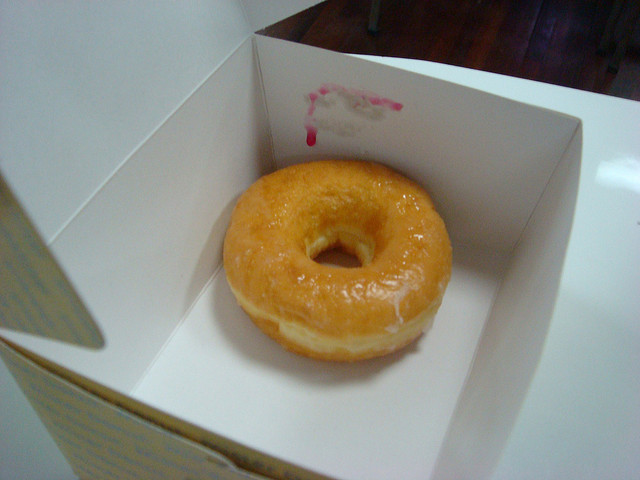Why do you think there's only one donut in the box? There could be several reasons for there being just one donut left in the box. It might be the last one remaining from a larger purchase, suggesting it was a shared treat, or it may have been bought individually as a personal indulgence. The solitary nature of the donut in its spacious box also seems to highlight its appeal and might evoke a sense of desire or temptation. 